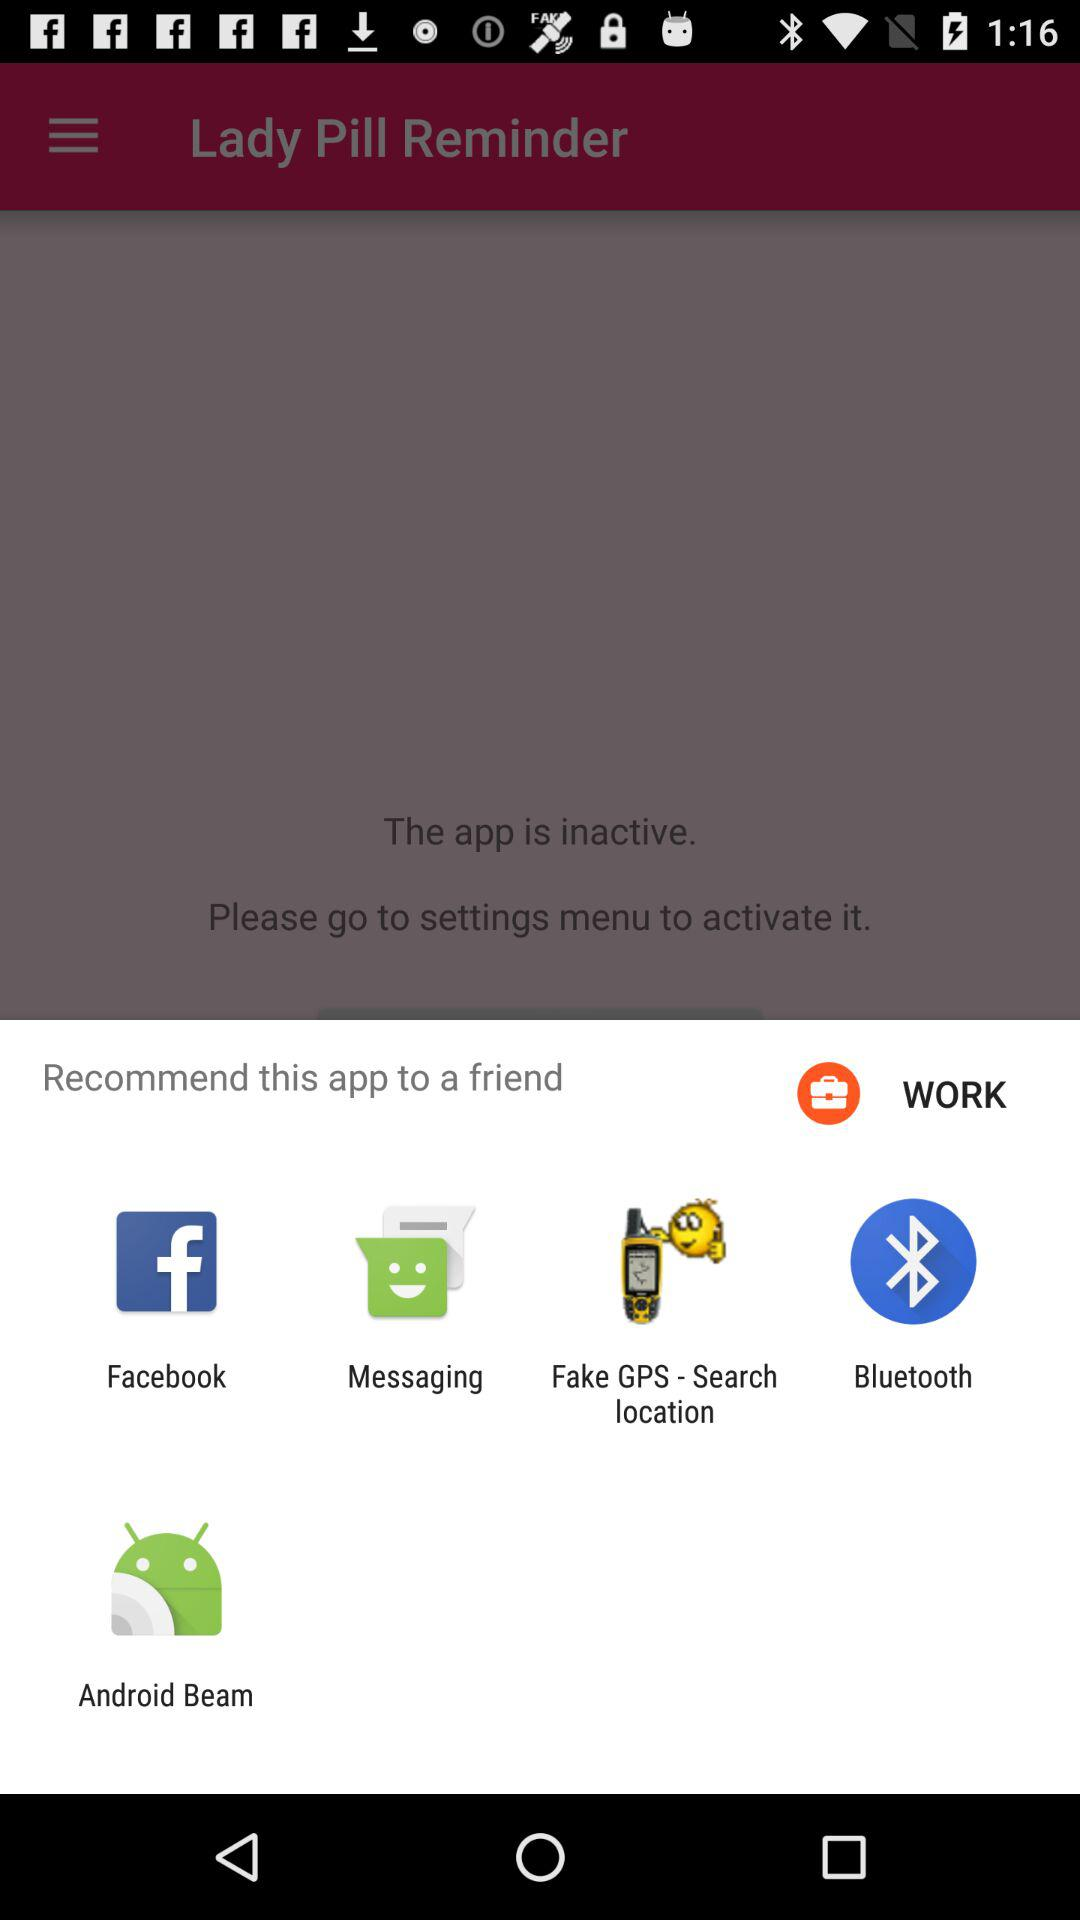What is the name of the application? The name of the application is "Lady Pill Reminder". 